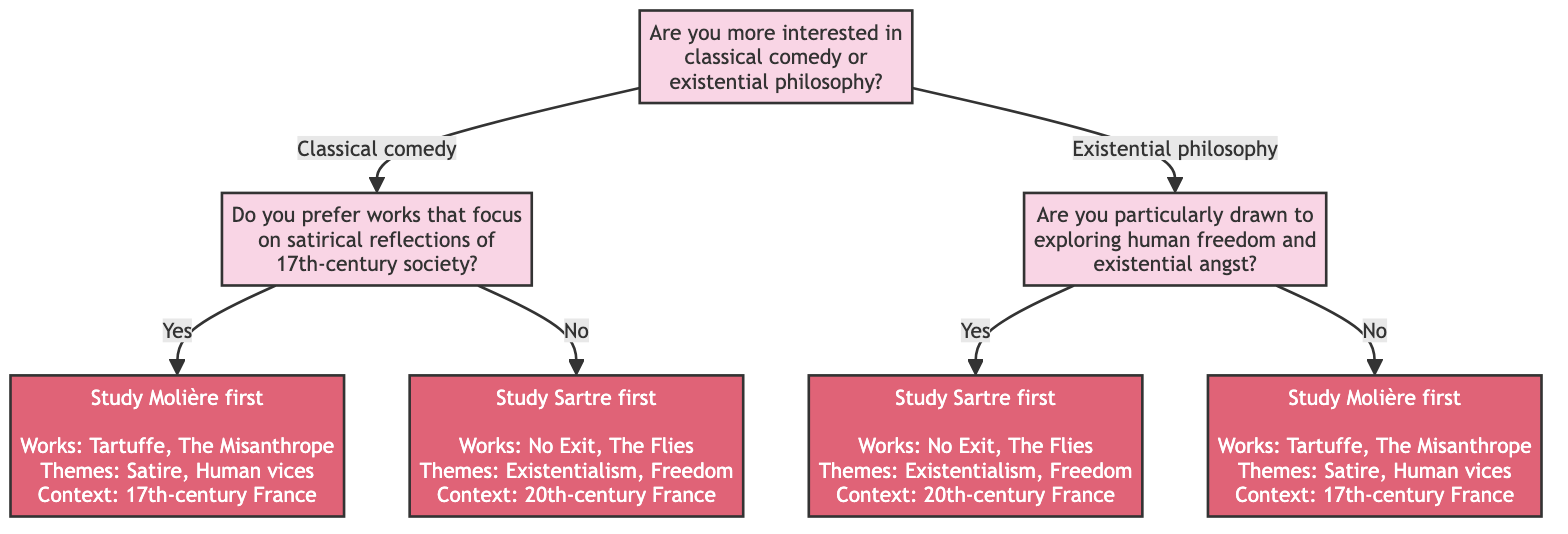Are you more interested in classical comedy or existential philosophy? This question is the root of the decision tree. It determines the initial path a user will take based on their interest, either leading towards classical comedy or existential philosophy.
Answer: classical comedy or existential philosophy What is the final option if you prefer works focused on satirical reflections of 17th-century society? Following the path from the answer "Classical comedy" to the question about satirical reflections of 17th-century society, answering "Yes" leads to the final option to study Molière first.
Answer: Study Molière first What themes are associated with Molière's works? In the final output for studying Molière first, themes listed include Satire and Human vices. This information is derived from the details under the Molière branch.
Answer: Satire, Human vices What are the important notes for studying Sartre first? In the final output for studying Sartre first, the important notes state that he is a key figure in existentialist philosophy and had a significant impact on modern and contemporary thought. This can be found under the details for Sartre’s works.
Answer: Key figure in existentialist philosophy How many works are listed for Molière? The details provided under Molière include three specific works: Tartuffe, The Misanthrope, and The School for Wives. Counting these gives a total.
Answer: 3 If you answer "No" to preferring satirical reflections of 17th-century society, what is the final option? Following the path for the "No" answer to the satirical reflections question leads to the conclusion to study Sartre first.
Answer: Study Sartre first What is the historical context for Sartre's works? The information under the details when concluding with Sartre states his context is 20th-century France, Post-WWII, integrating history with his works.
Answer: 20th-century France, Post-WWII What question follows "Existential philosophy" regarding human freedom? After choosing existential philosophy, the next question posed is about being particularly drawn to exploring human freedom and existential angst. This shows the next decision point.
Answer: Are you particularly drawn to exploring human freedom and existential angst? What kind of questions does this decision tree help to clarify? The tree is structured to guide users in determining which French playwright to study based on their interests in comedy or existential themes, making it a useful tool for students exploring theatre studies.
Answer: French playwright choice 